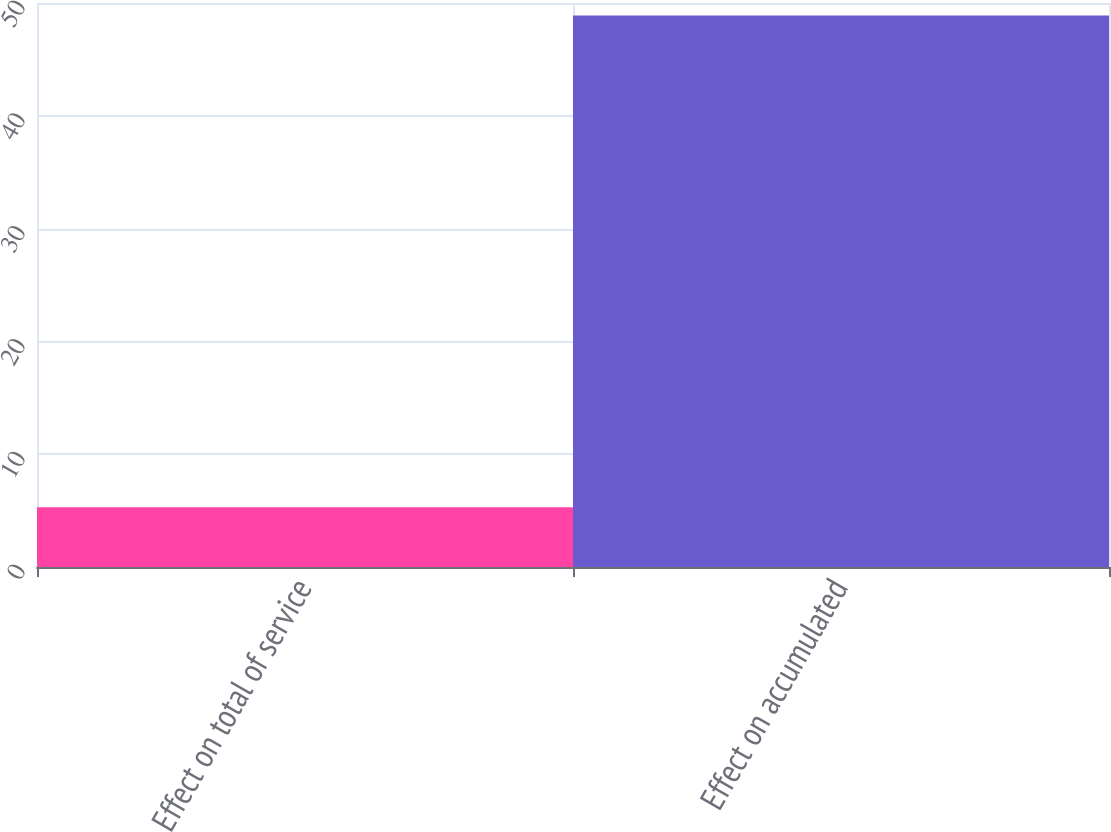<chart> <loc_0><loc_0><loc_500><loc_500><bar_chart><fcel>Effect on total of service<fcel>Effect on accumulated<nl><fcel>5.3<fcel>48.9<nl></chart> 